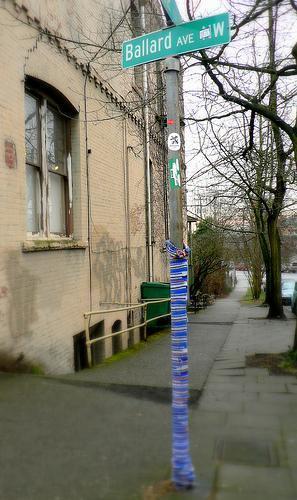How many buildings in picture?
Give a very brief answer. 1. 